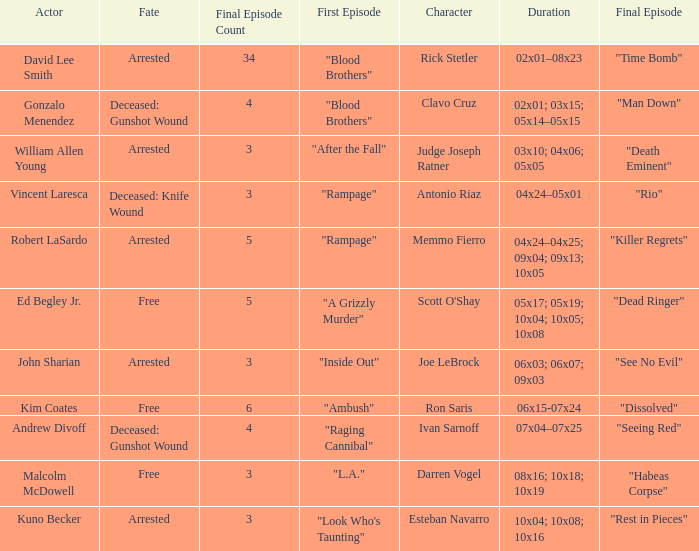What are all the actor where first episode is "ambush" Kim Coates. 